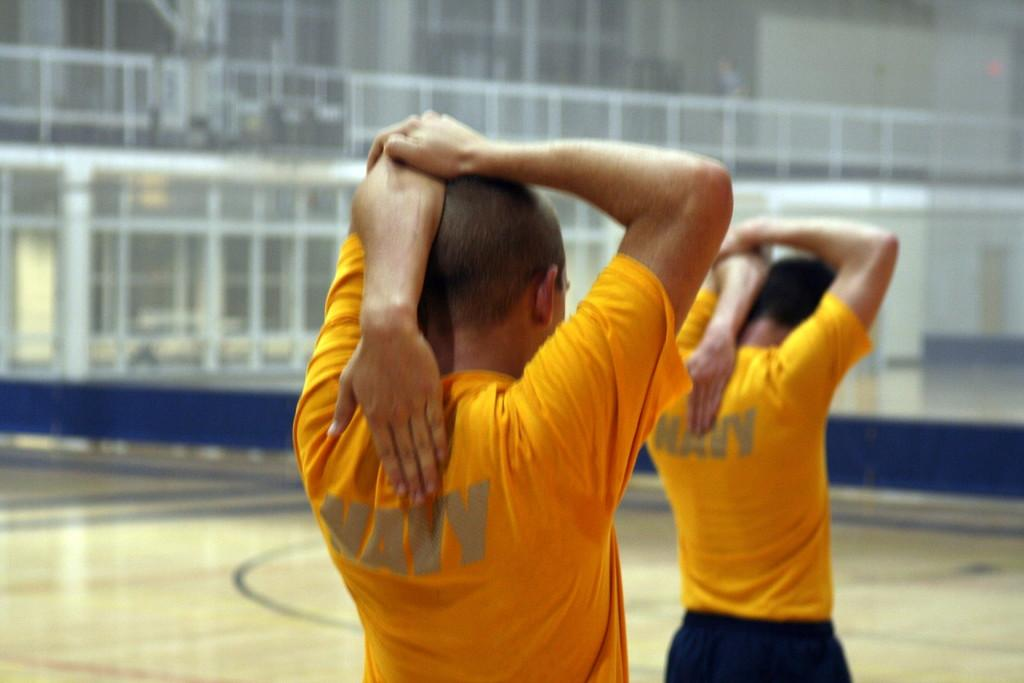How many people are in the image? There are two persons in the image. What are the people wearing? Both persons are wearing yellow t-shirts. What can be seen in the background of the image? There are rods in the background of the image. What is the surface on which the people are standing? There is a floor at the bottom of the image. What type of produce is being harvested by the persons in the image? There is no produce present in the image; the people are wearing yellow t-shirts and standing in front of rods. 